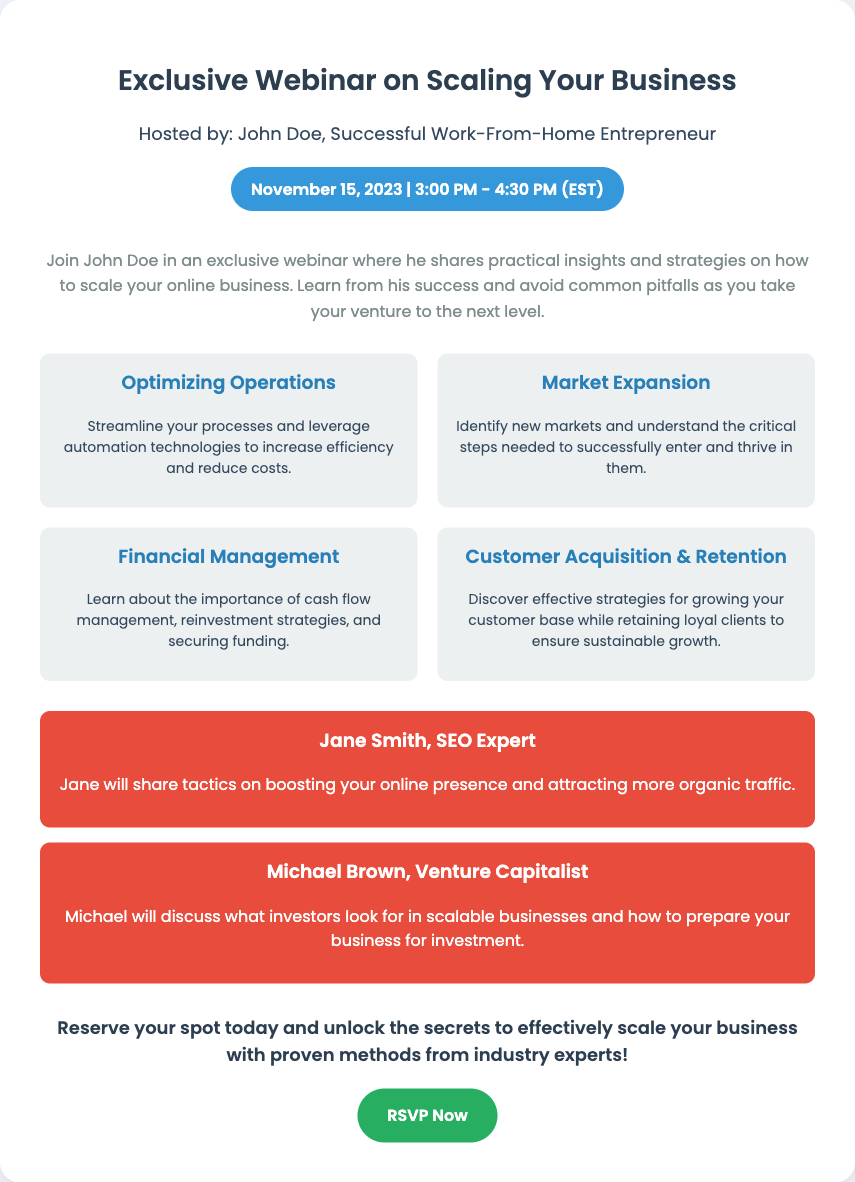What is the date of the webinar? The date is explicitly stated in the document as November 15, 2023.
Answer: November 15, 2023 Who is the host of the webinar? The host is mentioned in the sub-header of the card as John Doe.
Answer: John Doe What time does the webinar start? The start time is indicated in the date-time section as 3:00 PM.
Answer: 3:00 PM What is one of the key topics covered in the webinar? The document lists several key topics; one example is Optimizing Operations.
Answer: Optimizing Operations Who is one of the special guests? The document specifies two guests; one of them is Jane Smith.
Answer: Jane Smith What will Jane Smith discuss? Jane's topic is about boosting online presence and attracting organic traffic.
Answer: Boosting online presence What action is encouraged at the end of the card? The call-to-action suggests reserving a spot, indicated by "Reserve your spot today."
Answer: Reserve your spot How long is the webinar scheduled to last? The duration is provided as beginning at 3:00 PM and ending at 4:30 PM, which implies 1.5 hours.
Answer: 1.5 hours What color is the date-time label? The label is characterized by its background color, which is specified as blue (#3498db).
Answer: Blue 